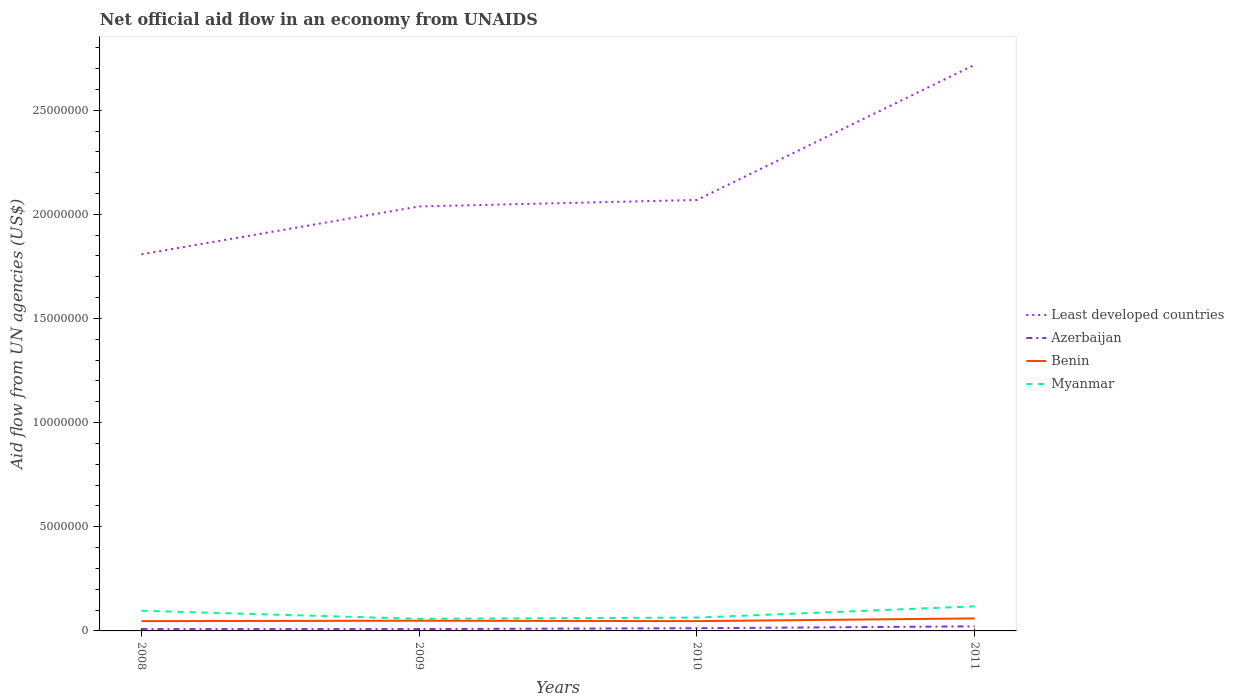Does the line corresponding to Myanmar intersect with the line corresponding to Benin?
Your answer should be compact. No. Across all years, what is the maximum net official aid flow in Azerbaijan?
Make the answer very short. 9.00e+04. In which year was the net official aid flow in Benin maximum?
Provide a short and direct response. 2008. What is the total net official aid flow in Least developed countries in the graph?
Your answer should be compact. -6.49e+06. What is the difference between the highest and the second highest net official aid flow in Least developed countries?
Your answer should be very brief. 9.10e+06. What is the difference between the highest and the lowest net official aid flow in Least developed countries?
Provide a short and direct response. 1. How many lines are there?
Offer a very short reply. 4. Does the graph contain any zero values?
Your answer should be very brief. No. Where does the legend appear in the graph?
Make the answer very short. Center right. How many legend labels are there?
Your response must be concise. 4. What is the title of the graph?
Keep it short and to the point. Net official aid flow in an economy from UNAIDS. What is the label or title of the Y-axis?
Make the answer very short. Aid flow from UN agencies (US$). What is the Aid flow from UN agencies (US$) of Least developed countries in 2008?
Provide a succinct answer. 1.81e+07. What is the Aid flow from UN agencies (US$) of Azerbaijan in 2008?
Give a very brief answer. 9.00e+04. What is the Aid flow from UN agencies (US$) of Myanmar in 2008?
Your answer should be very brief. 9.70e+05. What is the Aid flow from UN agencies (US$) of Least developed countries in 2009?
Your response must be concise. 2.04e+07. What is the Aid flow from UN agencies (US$) in Benin in 2009?
Provide a succinct answer. 4.90e+05. What is the Aid flow from UN agencies (US$) in Myanmar in 2009?
Your response must be concise. 5.80e+05. What is the Aid flow from UN agencies (US$) of Least developed countries in 2010?
Your answer should be very brief. 2.07e+07. What is the Aid flow from UN agencies (US$) of Myanmar in 2010?
Make the answer very short. 6.40e+05. What is the Aid flow from UN agencies (US$) of Least developed countries in 2011?
Give a very brief answer. 2.72e+07. What is the Aid flow from UN agencies (US$) of Azerbaijan in 2011?
Give a very brief answer. 2.20e+05. What is the Aid flow from UN agencies (US$) of Myanmar in 2011?
Your response must be concise. 1.18e+06. Across all years, what is the maximum Aid flow from UN agencies (US$) in Least developed countries?
Make the answer very short. 2.72e+07. Across all years, what is the maximum Aid flow from UN agencies (US$) of Azerbaijan?
Offer a terse response. 2.20e+05. Across all years, what is the maximum Aid flow from UN agencies (US$) in Myanmar?
Make the answer very short. 1.18e+06. Across all years, what is the minimum Aid flow from UN agencies (US$) of Least developed countries?
Make the answer very short. 1.81e+07. Across all years, what is the minimum Aid flow from UN agencies (US$) in Benin?
Offer a terse response. 4.70e+05. Across all years, what is the minimum Aid flow from UN agencies (US$) of Myanmar?
Ensure brevity in your answer.  5.80e+05. What is the total Aid flow from UN agencies (US$) in Least developed countries in the graph?
Your answer should be compact. 8.63e+07. What is the total Aid flow from UN agencies (US$) in Azerbaijan in the graph?
Provide a succinct answer. 5.30e+05. What is the total Aid flow from UN agencies (US$) in Benin in the graph?
Your response must be concise. 2.03e+06. What is the total Aid flow from UN agencies (US$) in Myanmar in the graph?
Your response must be concise. 3.37e+06. What is the difference between the Aid flow from UN agencies (US$) of Least developed countries in 2008 and that in 2009?
Make the answer very short. -2.30e+06. What is the difference between the Aid flow from UN agencies (US$) in Azerbaijan in 2008 and that in 2009?
Provide a short and direct response. 0. What is the difference between the Aid flow from UN agencies (US$) of Benin in 2008 and that in 2009?
Provide a succinct answer. -2.00e+04. What is the difference between the Aid flow from UN agencies (US$) in Least developed countries in 2008 and that in 2010?
Your response must be concise. -2.61e+06. What is the difference between the Aid flow from UN agencies (US$) in Azerbaijan in 2008 and that in 2010?
Make the answer very short. -4.00e+04. What is the difference between the Aid flow from UN agencies (US$) of Benin in 2008 and that in 2010?
Ensure brevity in your answer.  0. What is the difference between the Aid flow from UN agencies (US$) of Least developed countries in 2008 and that in 2011?
Offer a terse response. -9.10e+06. What is the difference between the Aid flow from UN agencies (US$) in Azerbaijan in 2008 and that in 2011?
Your response must be concise. -1.30e+05. What is the difference between the Aid flow from UN agencies (US$) of Benin in 2008 and that in 2011?
Your answer should be compact. -1.30e+05. What is the difference between the Aid flow from UN agencies (US$) of Myanmar in 2008 and that in 2011?
Your answer should be compact. -2.10e+05. What is the difference between the Aid flow from UN agencies (US$) of Least developed countries in 2009 and that in 2010?
Give a very brief answer. -3.10e+05. What is the difference between the Aid flow from UN agencies (US$) of Benin in 2009 and that in 2010?
Your answer should be very brief. 2.00e+04. What is the difference between the Aid flow from UN agencies (US$) of Myanmar in 2009 and that in 2010?
Give a very brief answer. -6.00e+04. What is the difference between the Aid flow from UN agencies (US$) of Least developed countries in 2009 and that in 2011?
Your answer should be compact. -6.80e+06. What is the difference between the Aid flow from UN agencies (US$) of Azerbaijan in 2009 and that in 2011?
Provide a short and direct response. -1.30e+05. What is the difference between the Aid flow from UN agencies (US$) in Benin in 2009 and that in 2011?
Your answer should be very brief. -1.10e+05. What is the difference between the Aid flow from UN agencies (US$) of Myanmar in 2009 and that in 2011?
Offer a very short reply. -6.00e+05. What is the difference between the Aid flow from UN agencies (US$) in Least developed countries in 2010 and that in 2011?
Ensure brevity in your answer.  -6.49e+06. What is the difference between the Aid flow from UN agencies (US$) of Myanmar in 2010 and that in 2011?
Offer a terse response. -5.40e+05. What is the difference between the Aid flow from UN agencies (US$) in Least developed countries in 2008 and the Aid flow from UN agencies (US$) in Azerbaijan in 2009?
Offer a terse response. 1.80e+07. What is the difference between the Aid flow from UN agencies (US$) in Least developed countries in 2008 and the Aid flow from UN agencies (US$) in Benin in 2009?
Your response must be concise. 1.76e+07. What is the difference between the Aid flow from UN agencies (US$) in Least developed countries in 2008 and the Aid flow from UN agencies (US$) in Myanmar in 2009?
Give a very brief answer. 1.75e+07. What is the difference between the Aid flow from UN agencies (US$) in Azerbaijan in 2008 and the Aid flow from UN agencies (US$) in Benin in 2009?
Give a very brief answer. -4.00e+05. What is the difference between the Aid flow from UN agencies (US$) of Azerbaijan in 2008 and the Aid flow from UN agencies (US$) of Myanmar in 2009?
Ensure brevity in your answer.  -4.90e+05. What is the difference between the Aid flow from UN agencies (US$) of Benin in 2008 and the Aid flow from UN agencies (US$) of Myanmar in 2009?
Provide a succinct answer. -1.10e+05. What is the difference between the Aid flow from UN agencies (US$) of Least developed countries in 2008 and the Aid flow from UN agencies (US$) of Azerbaijan in 2010?
Keep it short and to the point. 1.80e+07. What is the difference between the Aid flow from UN agencies (US$) in Least developed countries in 2008 and the Aid flow from UN agencies (US$) in Benin in 2010?
Your answer should be compact. 1.76e+07. What is the difference between the Aid flow from UN agencies (US$) of Least developed countries in 2008 and the Aid flow from UN agencies (US$) of Myanmar in 2010?
Provide a succinct answer. 1.74e+07. What is the difference between the Aid flow from UN agencies (US$) in Azerbaijan in 2008 and the Aid flow from UN agencies (US$) in Benin in 2010?
Offer a very short reply. -3.80e+05. What is the difference between the Aid flow from UN agencies (US$) of Azerbaijan in 2008 and the Aid flow from UN agencies (US$) of Myanmar in 2010?
Offer a very short reply. -5.50e+05. What is the difference between the Aid flow from UN agencies (US$) of Benin in 2008 and the Aid flow from UN agencies (US$) of Myanmar in 2010?
Offer a very short reply. -1.70e+05. What is the difference between the Aid flow from UN agencies (US$) of Least developed countries in 2008 and the Aid flow from UN agencies (US$) of Azerbaijan in 2011?
Offer a terse response. 1.79e+07. What is the difference between the Aid flow from UN agencies (US$) in Least developed countries in 2008 and the Aid flow from UN agencies (US$) in Benin in 2011?
Offer a terse response. 1.75e+07. What is the difference between the Aid flow from UN agencies (US$) of Least developed countries in 2008 and the Aid flow from UN agencies (US$) of Myanmar in 2011?
Your answer should be compact. 1.69e+07. What is the difference between the Aid flow from UN agencies (US$) in Azerbaijan in 2008 and the Aid flow from UN agencies (US$) in Benin in 2011?
Provide a succinct answer. -5.10e+05. What is the difference between the Aid flow from UN agencies (US$) of Azerbaijan in 2008 and the Aid flow from UN agencies (US$) of Myanmar in 2011?
Your response must be concise. -1.09e+06. What is the difference between the Aid flow from UN agencies (US$) of Benin in 2008 and the Aid flow from UN agencies (US$) of Myanmar in 2011?
Make the answer very short. -7.10e+05. What is the difference between the Aid flow from UN agencies (US$) of Least developed countries in 2009 and the Aid flow from UN agencies (US$) of Azerbaijan in 2010?
Make the answer very short. 2.02e+07. What is the difference between the Aid flow from UN agencies (US$) in Least developed countries in 2009 and the Aid flow from UN agencies (US$) in Benin in 2010?
Your answer should be very brief. 1.99e+07. What is the difference between the Aid flow from UN agencies (US$) in Least developed countries in 2009 and the Aid flow from UN agencies (US$) in Myanmar in 2010?
Your response must be concise. 1.97e+07. What is the difference between the Aid flow from UN agencies (US$) of Azerbaijan in 2009 and the Aid flow from UN agencies (US$) of Benin in 2010?
Your answer should be very brief. -3.80e+05. What is the difference between the Aid flow from UN agencies (US$) in Azerbaijan in 2009 and the Aid flow from UN agencies (US$) in Myanmar in 2010?
Provide a short and direct response. -5.50e+05. What is the difference between the Aid flow from UN agencies (US$) of Least developed countries in 2009 and the Aid flow from UN agencies (US$) of Azerbaijan in 2011?
Your answer should be compact. 2.02e+07. What is the difference between the Aid flow from UN agencies (US$) of Least developed countries in 2009 and the Aid flow from UN agencies (US$) of Benin in 2011?
Keep it short and to the point. 1.98e+07. What is the difference between the Aid flow from UN agencies (US$) in Least developed countries in 2009 and the Aid flow from UN agencies (US$) in Myanmar in 2011?
Offer a terse response. 1.92e+07. What is the difference between the Aid flow from UN agencies (US$) of Azerbaijan in 2009 and the Aid flow from UN agencies (US$) of Benin in 2011?
Offer a very short reply. -5.10e+05. What is the difference between the Aid flow from UN agencies (US$) of Azerbaijan in 2009 and the Aid flow from UN agencies (US$) of Myanmar in 2011?
Your response must be concise. -1.09e+06. What is the difference between the Aid flow from UN agencies (US$) of Benin in 2009 and the Aid flow from UN agencies (US$) of Myanmar in 2011?
Give a very brief answer. -6.90e+05. What is the difference between the Aid flow from UN agencies (US$) of Least developed countries in 2010 and the Aid flow from UN agencies (US$) of Azerbaijan in 2011?
Make the answer very short. 2.05e+07. What is the difference between the Aid flow from UN agencies (US$) of Least developed countries in 2010 and the Aid flow from UN agencies (US$) of Benin in 2011?
Provide a succinct answer. 2.01e+07. What is the difference between the Aid flow from UN agencies (US$) in Least developed countries in 2010 and the Aid flow from UN agencies (US$) in Myanmar in 2011?
Your answer should be compact. 1.95e+07. What is the difference between the Aid flow from UN agencies (US$) in Azerbaijan in 2010 and the Aid flow from UN agencies (US$) in Benin in 2011?
Provide a succinct answer. -4.70e+05. What is the difference between the Aid flow from UN agencies (US$) in Azerbaijan in 2010 and the Aid flow from UN agencies (US$) in Myanmar in 2011?
Keep it short and to the point. -1.05e+06. What is the difference between the Aid flow from UN agencies (US$) in Benin in 2010 and the Aid flow from UN agencies (US$) in Myanmar in 2011?
Ensure brevity in your answer.  -7.10e+05. What is the average Aid flow from UN agencies (US$) of Least developed countries per year?
Keep it short and to the point. 2.16e+07. What is the average Aid flow from UN agencies (US$) in Azerbaijan per year?
Your answer should be very brief. 1.32e+05. What is the average Aid flow from UN agencies (US$) in Benin per year?
Provide a succinct answer. 5.08e+05. What is the average Aid flow from UN agencies (US$) in Myanmar per year?
Provide a succinct answer. 8.42e+05. In the year 2008, what is the difference between the Aid flow from UN agencies (US$) of Least developed countries and Aid flow from UN agencies (US$) of Azerbaijan?
Provide a succinct answer. 1.80e+07. In the year 2008, what is the difference between the Aid flow from UN agencies (US$) in Least developed countries and Aid flow from UN agencies (US$) in Benin?
Make the answer very short. 1.76e+07. In the year 2008, what is the difference between the Aid flow from UN agencies (US$) of Least developed countries and Aid flow from UN agencies (US$) of Myanmar?
Your response must be concise. 1.71e+07. In the year 2008, what is the difference between the Aid flow from UN agencies (US$) in Azerbaijan and Aid flow from UN agencies (US$) in Benin?
Offer a terse response. -3.80e+05. In the year 2008, what is the difference between the Aid flow from UN agencies (US$) of Azerbaijan and Aid flow from UN agencies (US$) of Myanmar?
Make the answer very short. -8.80e+05. In the year 2008, what is the difference between the Aid flow from UN agencies (US$) in Benin and Aid flow from UN agencies (US$) in Myanmar?
Your answer should be very brief. -5.00e+05. In the year 2009, what is the difference between the Aid flow from UN agencies (US$) in Least developed countries and Aid flow from UN agencies (US$) in Azerbaijan?
Provide a succinct answer. 2.03e+07. In the year 2009, what is the difference between the Aid flow from UN agencies (US$) of Least developed countries and Aid flow from UN agencies (US$) of Benin?
Offer a very short reply. 1.99e+07. In the year 2009, what is the difference between the Aid flow from UN agencies (US$) in Least developed countries and Aid flow from UN agencies (US$) in Myanmar?
Your answer should be very brief. 1.98e+07. In the year 2009, what is the difference between the Aid flow from UN agencies (US$) of Azerbaijan and Aid flow from UN agencies (US$) of Benin?
Offer a terse response. -4.00e+05. In the year 2009, what is the difference between the Aid flow from UN agencies (US$) of Azerbaijan and Aid flow from UN agencies (US$) of Myanmar?
Provide a succinct answer. -4.90e+05. In the year 2010, what is the difference between the Aid flow from UN agencies (US$) in Least developed countries and Aid flow from UN agencies (US$) in Azerbaijan?
Provide a short and direct response. 2.06e+07. In the year 2010, what is the difference between the Aid flow from UN agencies (US$) of Least developed countries and Aid flow from UN agencies (US$) of Benin?
Keep it short and to the point. 2.02e+07. In the year 2010, what is the difference between the Aid flow from UN agencies (US$) in Least developed countries and Aid flow from UN agencies (US$) in Myanmar?
Provide a succinct answer. 2.00e+07. In the year 2010, what is the difference between the Aid flow from UN agencies (US$) of Azerbaijan and Aid flow from UN agencies (US$) of Myanmar?
Offer a terse response. -5.10e+05. In the year 2010, what is the difference between the Aid flow from UN agencies (US$) of Benin and Aid flow from UN agencies (US$) of Myanmar?
Provide a succinct answer. -1.70e+05. In the year 2011, what is the difference between the Aid flow from UN agencies (US$) in Least developed countries and Aid flow from UN agencies (US$) in Azerbaijan?
Offer a very short reply. 2.70e+07. In the year 2011, what is the difference between the Aid flow from UN agencies (US$) of Least developed countries and Aid flow from UN agencies (US$) of Benin?
Provide a short and direct response. 2.66e+07. In the year 2011, what is the difference between the Aid flow from UN agencies (US$) of Least developed countries and Aid flow from UN agencies (US$) of Myanmar?
Provide a short and direct response. 2.60e+07. In the year 2011, what is the difference between the Aid flow from UN agencies (US$) of Azerbaijan and Aid flow from UN agencies (US$) of Benin?
Provide a short and direct response. -3.80e+05. In the year 2011, what is the difference between the Aid flow from UN agencies (US$) of Azerbaijan and Aid flow from UN agencies (US$) of Myanmar?
Offer a terse response. -9.60e+05. In the year 2011, what is the difference between the Aid flow from UN agencies (US$) of Benin and Aid flow from UN agencies (US$) of Myanmar?
Make the answer very short. -5.80e+05. What is the ratio of the Aid flow from UN agencies (US$) of Least developed countries in 2008 to that in 2009?
Make the answer very short. 0.89. What is the ratio of the Aid flow from UN agencies (US$) in Azerbaijan in 2008 to that in 2009?
Your response must be concise. 1. What is the ratio of the Aid flow from UN agencies (US$) of Benin in 2008 to that in 2009?
Provide a short and direct response. 0.96. What is the ratio of the Aid flow from UN agencies (US$) of Myanmar in 2008 to that in 2009?
Make the answer very short. 1.67. What is the ratio of the Aid flow from UN agencies (US$) in Least developed countries in 2008 to that in 2010?
Ensure brevity in your answer.  0.87. What is the ratio of the Aid flow from UN agencies (US$) of Azerbaijan in 2008 to that in 2010?
Provide a succinct answer. 0.69. What is the ratio of the Aid flow from UN agencies (US$) of Myanmar in 2008 to that in 2010?
Offer a very short reply. 1.52. What is the ratio of the Aid flow from UN agencies (US$) in Least developed countries in 2008 to that in 2011?
Offer a very short reply. 0.67. What is the ratio of the Aid flow from UN agencies (US$) in Azerbaijan in 2008 to that in 2011?
Make the answer very short. 0.41. What is the ratio of the Aid flow from UN agencies (US$) of Benin in 2008 to that in 2011?
Ensure brevity in your answer.  0.78. What is the ratio of the Aid flow from UN agencies (US$) of Myanmar in 2008 to that in 2011?
Your response must be concise. 0.82. What is the ratio of the Aid flow from UN agencies (US$) of Azerbaijan in 2009 to that in 2010?
Give a very brief answer. 0.69. What is the ratio of the Aid flow from UN agencies (US$) in Benin in 2009 to that in 2010?
Provide a short and direct response. 1.04. What is the ratio of the Aid flow from UN agencies (US$) in Myanmar in 2009 to that in 2010?
Ensure brevity in your answer.  0.91. What is the ratio of the Aid flow from UN agencies (US$) in Least developed countries in 2009 to that in 2011?
Provide a succinct answer. 0.75. What is the ratio of the Aid flow from UN agencies (US$) in Azerbaijan in 2009 to that in 2011?
Provide a short and direct response. 0.41. What is the ratio of the Aid flow from UN agencies (US$) in Benin in 2009 to that in 2011?
Offer a very short reply. 0.82. What is the ratio of the Aid flow from UN agencies (US$) in Myanmar in 2009 to that in 2011?
Ensure brevity in your answer.  0.49. What is the ratio of the Aid flow from UN agencies (US$) in Least developed countries in 2010 to that in 2011?
Ensure brevity in your answer.  0.76. What is the ratio of the Aid flow from UN agencies (US$) in Azerbaijan in 2010 to that in 2011?
Provide a short and direct response. 0.59. What is the ratio of the Aid flow from UN agencies (US$) of Benin in 2010 to that in 2011?
Make the answer very short. 0.78. What is the ratio of the Aid flow from UN agencies (US$) in Myanmar in 2010 to that in 2011?
Make the answer very short. 0.54. What is the difference between the highest and the second highest Aid flow from UN agencies (US$) in Least developed countries?
Provide a succinct answer. 6.49e+06. What is the difference between the highest and the second highest Aid flow from UN agencies (US$) of Benin?
Offer a terse response. 1.10e+05. What is the difference between the highest and the lowest Aid flow from UN agencies (US$) of Least developed countries?
Offer a terse response. 9.10e+06. What is the difference between the highest and the lowest Aid flow from UN agencies (US$) in Azerbaijan?
Your answer should be very brief. 1.30e+05. What is the difference between the highest and the lowest Aid flow from UN agencies (US$) in Benin?
Make the answer very short. 1.30e+05. 